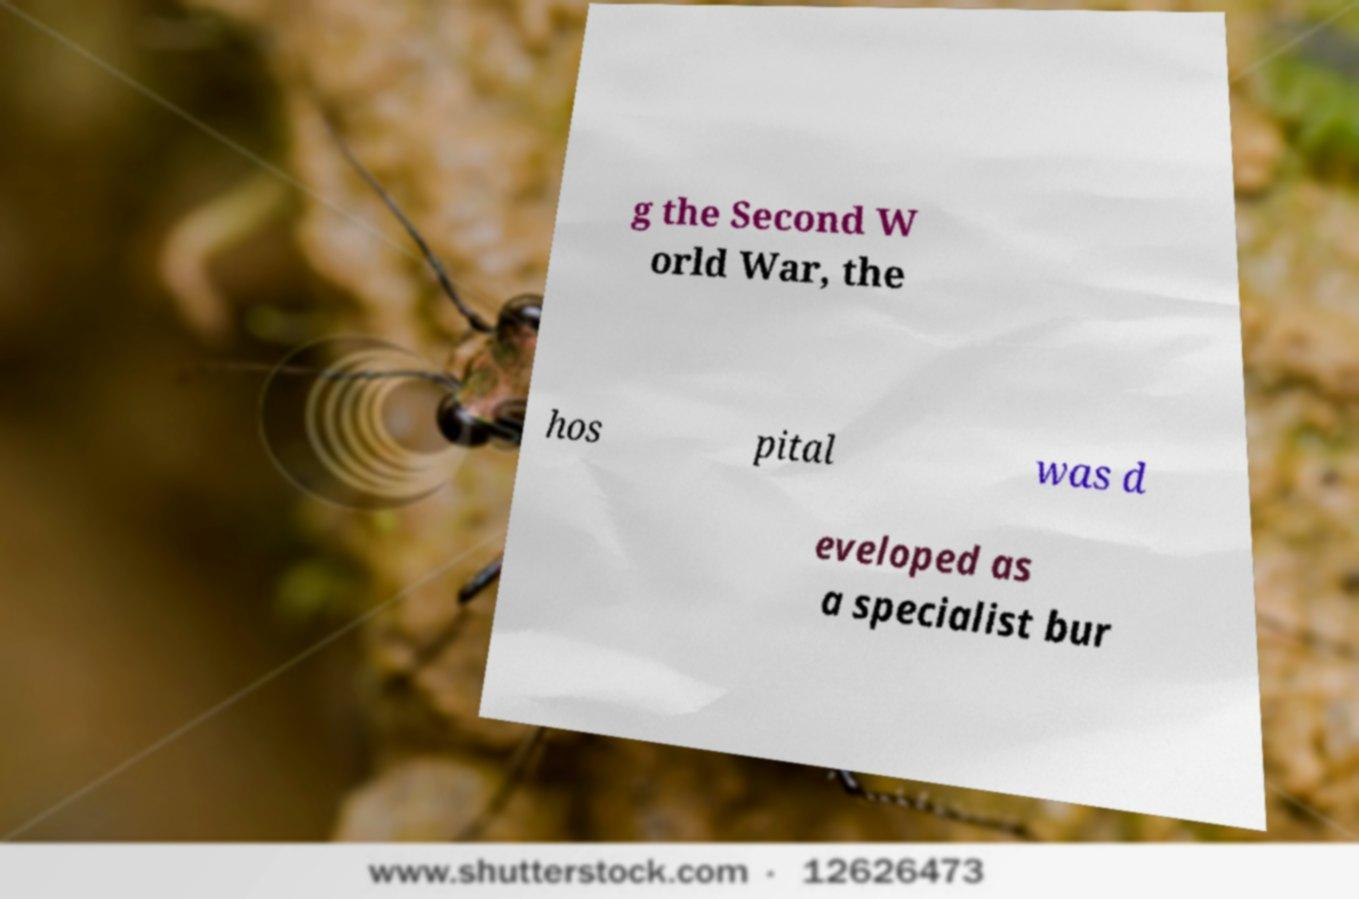Could you assist in decoding the text presented in this image and type it out clearly? g the Second W orld War, the hos pital was d eveloped as a specialist bur 